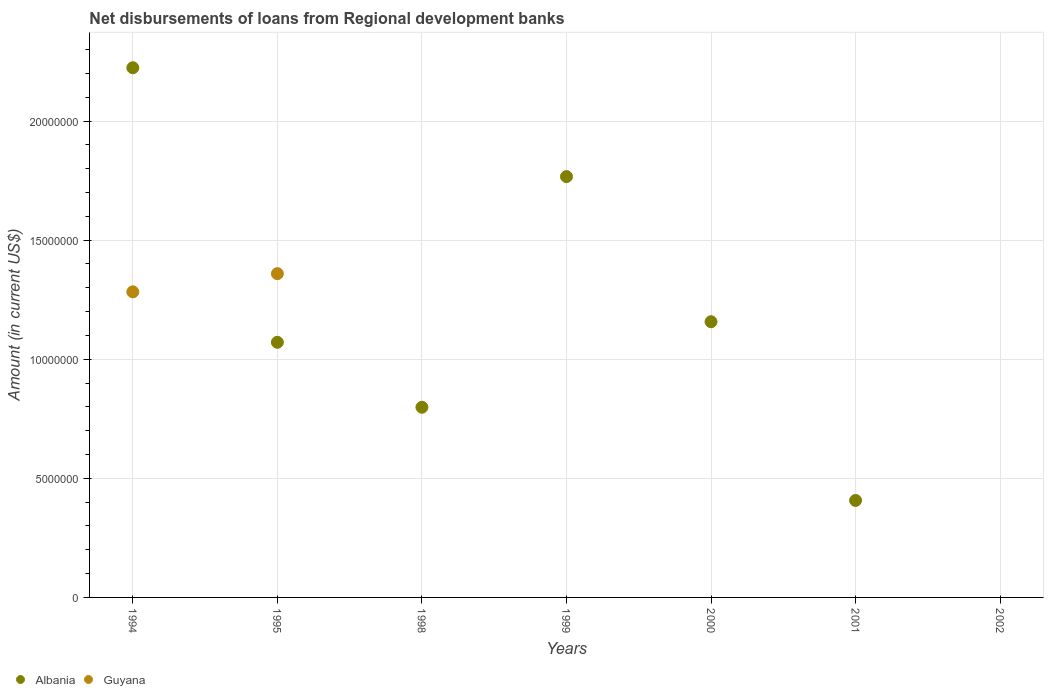How many different coloured dotlines are there?
Keep it short and to the point. 2. What is the amount of disbursements of loans from regional development banks in Albania in 2000?
Keep it short and to the point. 1.16e+07. Across all years, what is the maximum amount of disbursements of loans from regional development banks in Guyana?
Keep it short and to the point. 1.36e+07. What is the total amount of disbursements of loans from regional development banks in Albania in the graph?
Offer a terse response. 7.43e+07. What is the difference between the amount of disbursements of loans from regional development banks in Albania in 1994 and that in 2000?
Make the answer very short. 1.07e+07. What is the difference between the amount of disbursements of loans from regional development banks in Albania in 1995 and the amount of disbursements of loans from regional development banks in Guyana in 2000?
Keep it short and to the point. 1.07e+07. What is the average amount of disbursements of loans from regional development banks in Albania per year?
Your answer should be very brief. 1.06e+07. In the year 1994, what is the difference between the amount of disbursements of loans from regional development banks in Guyana and amount of disbursements of loans from regional development banks in Albania?
Provide a succinct answer. -9.41e+06. What is the ratio of the amount of disbursements of loans from regional development banks in Albania in 1994 to that in 2001?
Your answer should be compact. 5.46. What is the difference between the highest and the second highest amount of disbursements of loans from regional development banks in Albania?
Give a very brief answer. 4.57e+06. What is the difference between the highest and the lowest amount of disbursements of loans from regional development banks in Albania?
Make the answer very short. 2.22e+07. Is the amount of disbursements of loans from regional development banks in Albania strictly less than the amount of disbursements of loans from regional development banks in Guyana over the years?
Offer a very short reply. No. How many dotlines are there?
Ensure brevity in your answer.  2. How many years are there in the graph?
Keep it short and to the point. 7. Does the graph contain any zero values?
Your answer should be compact. Yes. Where does the legend appear in the graph?
Offer a very short reply. Bottom left. What is the title of the graph?
Make the answer very short. Net disbursements of loans from Regional development banks. Does "Egypt, Arab Rep." appear as one of the legend labels in the graph?
Give a very brief answer. No. What is the label or title of the X-axis?
Provide a succinct answer. Years. What is the Amount (in current US$) in Albania in 1994?
Provide a succinct answer. 2.22e+07. What is the Amount (in current US$) of Guyana in 1994?
Provide a short and direct response. 1.28e+07. What is the Amount (in current US$) in Albania in 1995?
Make the answer very short. 1.07e+07. What is the Amount (in current US$) of Guyana in 1995?
Give a very brief answer. 1.36e+07. What is the Amount (in current US$) of Albania in 1998?
Provide a short and direct response. 7.98e+06. What is the Amount (in current US$) in Guyana in 1998?
Provide a short and direct response. 0. What is the Amount (in current US$) in Albania in 1999?
Give a very brief answer. 1.77e+07. What is the Amount (in current US$) in Guyana in 1999?
Keep it short and to the point. 0. What is the Amount (in current US$) of Albania in 2000?
Give a very brief answer. 1.16e+07. What is the Amount (in current US$) in Albania in 2001?
Make the answer very short. 4.07e+06. What is the Amount (in current US$) of Albania in 2002?
Give a very brief answer. 0. What is the Amount (in current US$) in Guyana in 2002?
Offer a very short reply. 0. Across all years, what is the maximum Amount (in current US$) of Albania?
Your response must be concise. 2.22e+07. Across all years, what is the maximum Amount (in current US$) in Guyana?
Your answer should be compact. 1.36e+07. Across all years, what is the minimum Amount (in current US$) in Guyana?
Offer a terse response. 0. What is the total Amount (in current US$) of Albania in the graph?
Your response must be concise. 7.43e+07. What is the total Amount (in current US$) of Guyana in the graph?
Make the answer very short. 2.64e+07. What is the difference between the Amount (in current US$) of Albania in 1994 and that in 1995?
Provide a succinct answer. 1.15e+07. What is the difference between the Amount (in current US$) in Guyana in 1994 and that in 1995?
Ensure brevity in your answer.  -7.63e+05. What is the difference between the Amount (in current US$) of Albania in 1994 and that in 1998?
Your answer should be compact. 1.43e+07. What is the difference between the Amount (in current US$) of Albania in 1994 and that in 1999?
Your response must be concise. 4.57e+06. What is the difference between the Amount (in current US$) in Albania in 1994 and that in 2000?
Your response must be concise. 1.07e+07. What is the difference between the Amount (in current US$) in Albania in 1994 and that in 2001?
Your response must be concise. 1.82e+07. What is the difference between the Amount (in current US$) of Albania in 1995 and that in 1998?
Provide a succinct answer. 2.73e+06. What is the difference between the Amount (in current US$) of Albania in 1995 and that in 1999?
Offer a very short reply. -6.96e+06. What is the difference between the Amount (in current US$) of Albania in 1995 and that in 2000?
Offer a very short reply. -8.64e+05. What is the difference between the Amount (in current US$) in Albania in 1995 and that in 2001?
Your response must be concise. 6.64e+06. What is the difference between the Amount (in current US$) of Albania in 1998 and that in 1999?
Give a very brief answer. -9.68e+06. What is the difference between the Amount (in current US$) in Albania in 1998 and that in 2000?
Offer a terse response. -3.59e+06. What is the difference between the Amount (in current US$) of Albania in 1998 and that in 2001?
Your response must be concise. 3.91e+06. What is the difference between the Amount (in current US$) in Albania in 1999 and that in 2000?
Provide a short and direct response. 6.09e+06. What is the difference between the Amount (in current US$) of Albania in 1999 and that in 2001?
Your answer should be very brief. 1.36e+07. What is the difference between the Amount (in current US$) of Albania in 2000 and that in 2001?
Keep it short and to the point. 7.50e+06. What is the difference between the Amount (in current US$) in Albania in 1994 and the Amount (in current US$) in Guyana in 1995?
Your answer should be very brief. 8.65e+06. What is the average Amount (in current US$) in Albania per year?
Your response must be concise. 1.06e+07. What is the average Amount (in current US$) in Guyana per year?
Provide a short and direct response. 3.78e+06. In the year 1994, what is the difference between the Amount (in current US$) in Albania and Amount (in current US$) in Guyana?
Your response must be concise. 9.41e+06. In the year 1995, what is the difference between the Amount (in current US$) in Albania and Amount (in current US$) in Guyana?
Provide a succinct answer. -2.88e+06. What is the ratio of the Amount (in current US$) of Albania in 1994 to that in 1995?
Give a very brief answer. 2.08. What is the ratio of the Amount (in current US$) in Guyana in 1994 to that in 1995?
Give a very brief answer. 0.94. What is the ratio of the Amount (in current US$) of Albania in 1994 to that in 1998?
Give a very brief answer. 2.79. What is the ratio of the Amount (in current US$) of Albania in 1994 to that in 1999?
Ensure brevity in your answer.  1.26. What is the ratio of the Amount (in current US$) in Albania in 1994 to that in 2000?
Offer a very short reply. 1.92. What is the ratio of the Amount (in current US$) of Albania in 1994 to that in 2001?
Your answer should be compact. 5.46. What is the ratio of the Amount (in current US$) in Albania in 1995 to that in 1998?
Give a very brief answer. 1.34. What is the ratio of the Amount (in current US$) in Albania in 1995 to that in 1999?
Keep it short and to the point. 0.61. What is the ratio of the Amount (in current US$) of Albania in 1995 to that in 2000?
Your answer should be very brief. 0.93. What is the ratio of the Amount (in current US$) in Albania in 1995 to that in 2001?
Your response must be concise. 2.63. What is the ratio of the Amount (in current US$) in Albania in 1998 to that in 1999?
Your answer should be compact. 0.45. What is the ratio of the Amount (in current US$) of Albania in 1998 to that in 2000?
Offer a very short reply. 0.69. What is the ratio of the Amount (in current US$) of Albania in 1998 to that in 2001?
Make the answer very short. 1.96. What is the ratio of the Amount (in current US$) of Albania in 1999 to that in 2000?
Keep it short and to the point. 1.53. What is the ratio of the Amount (in current US$) of Albania in 1999 to that in 2001?
Your answer should be compact. 4.34. What is the ratio of the Amount (in current US$) of Albania in 2000 to that in 2001?
Make the answer very short. 2.84. What is the difference between the highest and the second highest Amount (in current US$) in Albania?
Make the answer very short. 4.57e+06. What is the difference between the highest and the lowest Amount (in current US$) in Albania?
Give a very brief answer. 2.22e+07. What is the difference between the highest and the lowest Amount (in current US$) of Guyana?
Your response must be concise. 1.36e+07. 